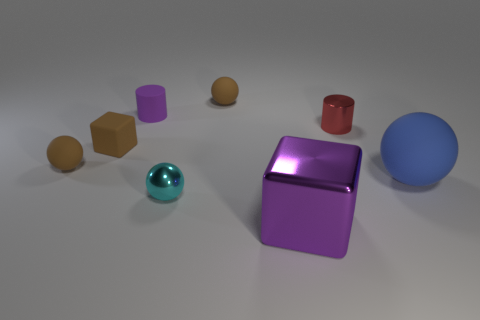Subtract all tiny spheres. How many spheres are left? 1 Add 1 blue things. How many objects exist? 9 Subtract 2 balls. How many balls are left? 2 Subtract all cyan spheres. How many spheres are left? 3 Add 8 big green shiny cylinders. How many big green shiny cylinders exist? 8 Subtract 1 red cylinders. How many objects are left? 7 Subtract all blue cubes. Subtract all gray cylinders. How many cubes are left? 2 Subtract all green spheres. How many yellow blocks are left? 0 Subtract all big purple metal cubes. Subtract all matte cylinders. How many objects are left? 6 Add 2 small cubes. How many small cubes are left? 3 